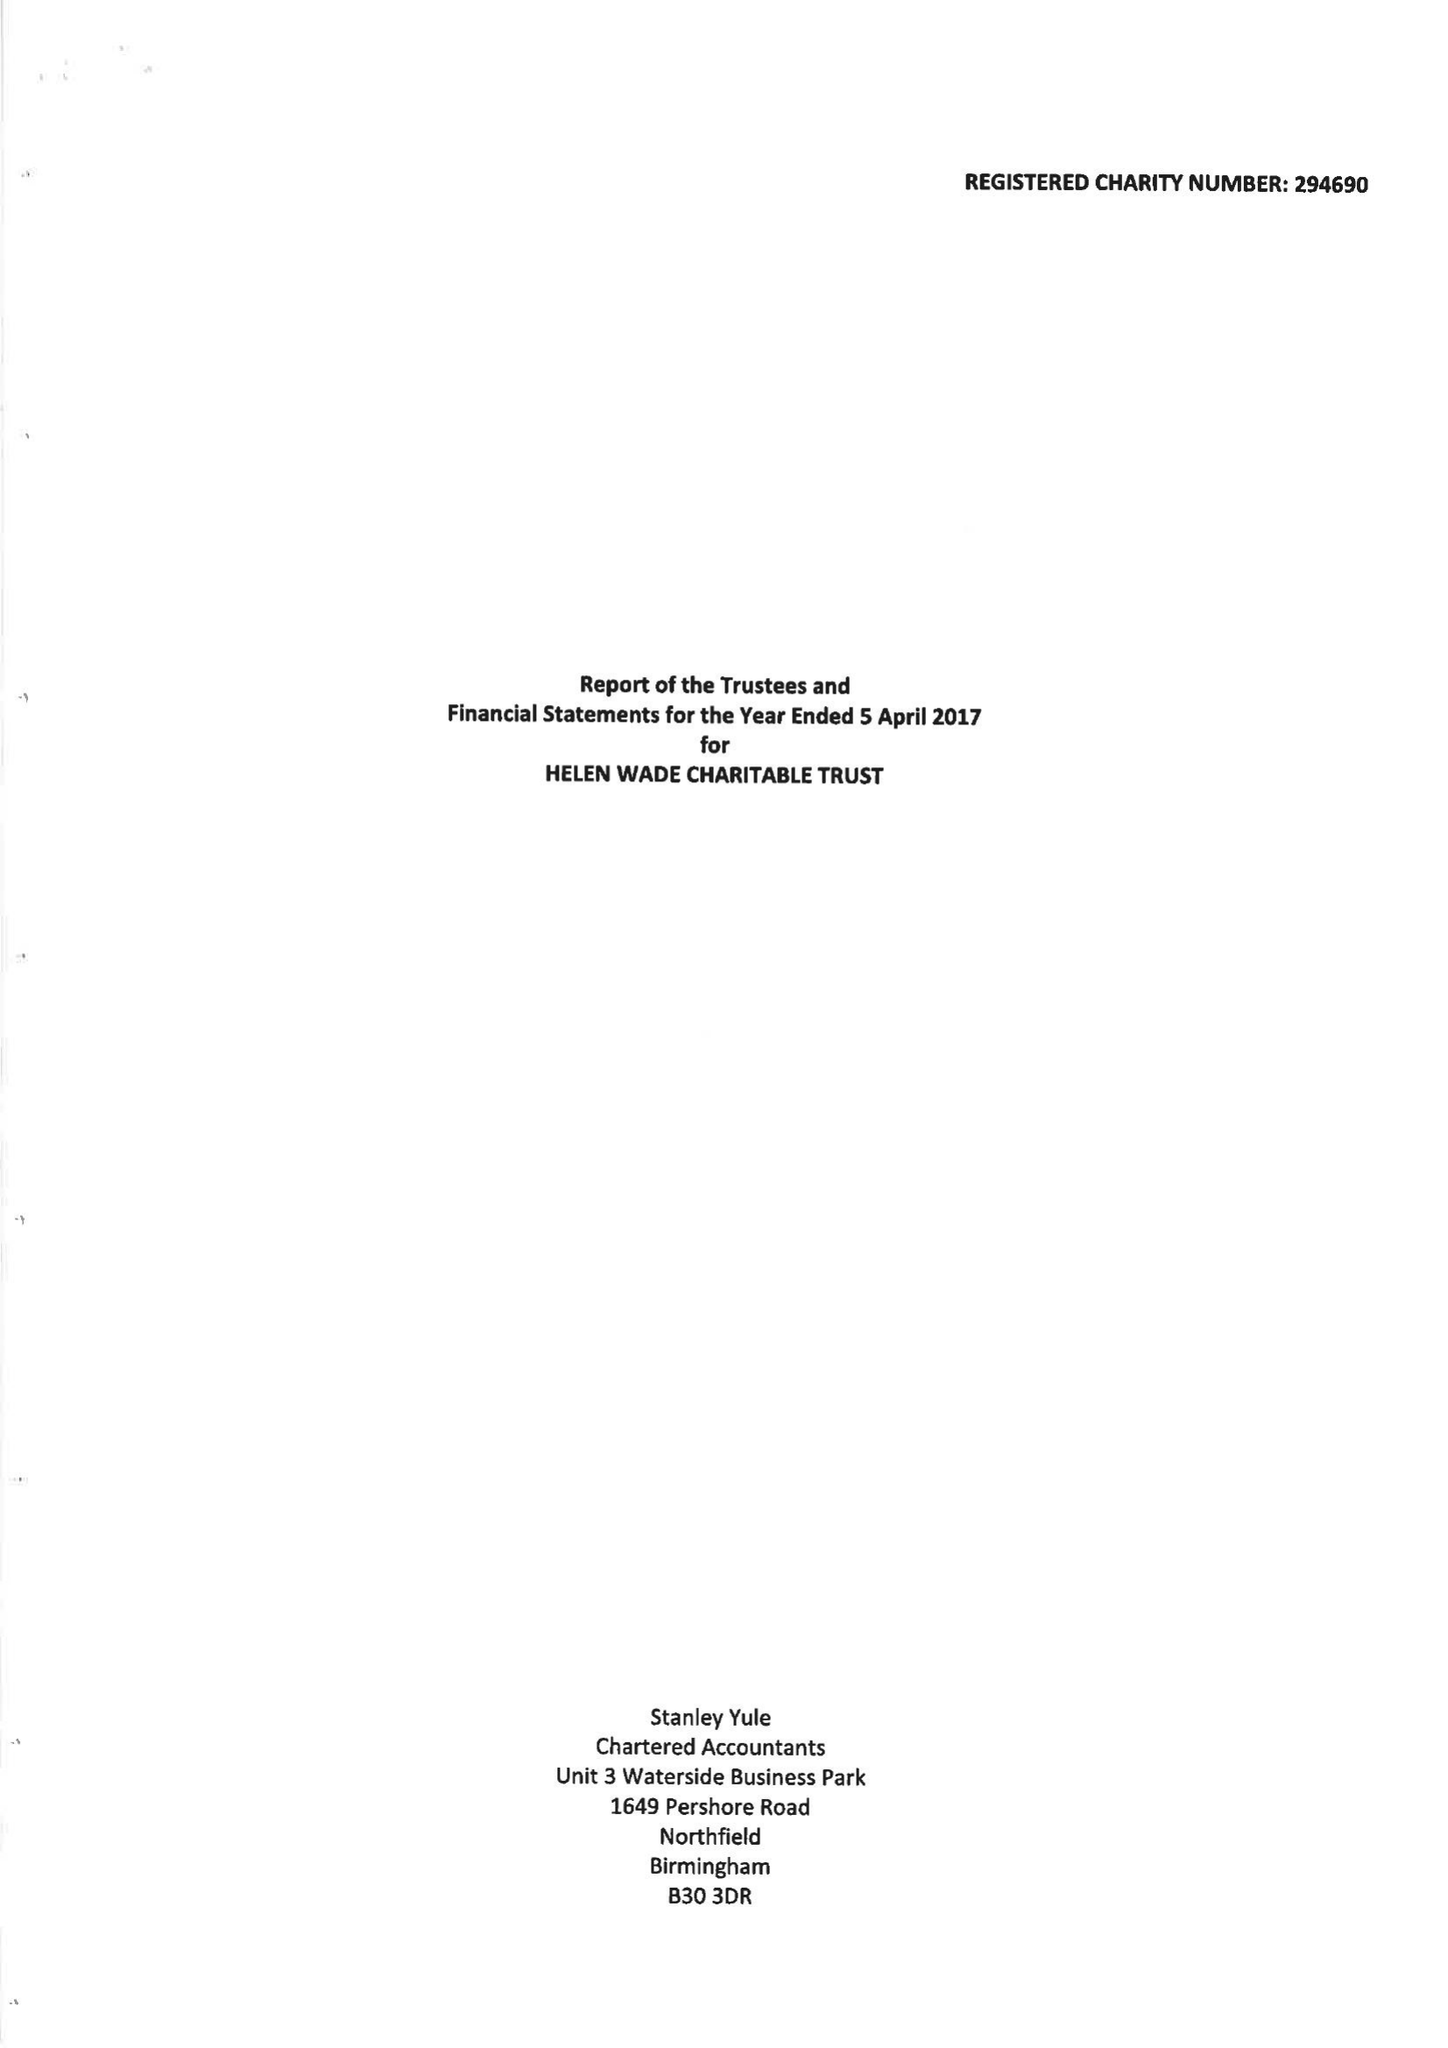What is the value for the income_annually_in_british_pounds?
Answer the question using a single word or phrase. 38546.00 